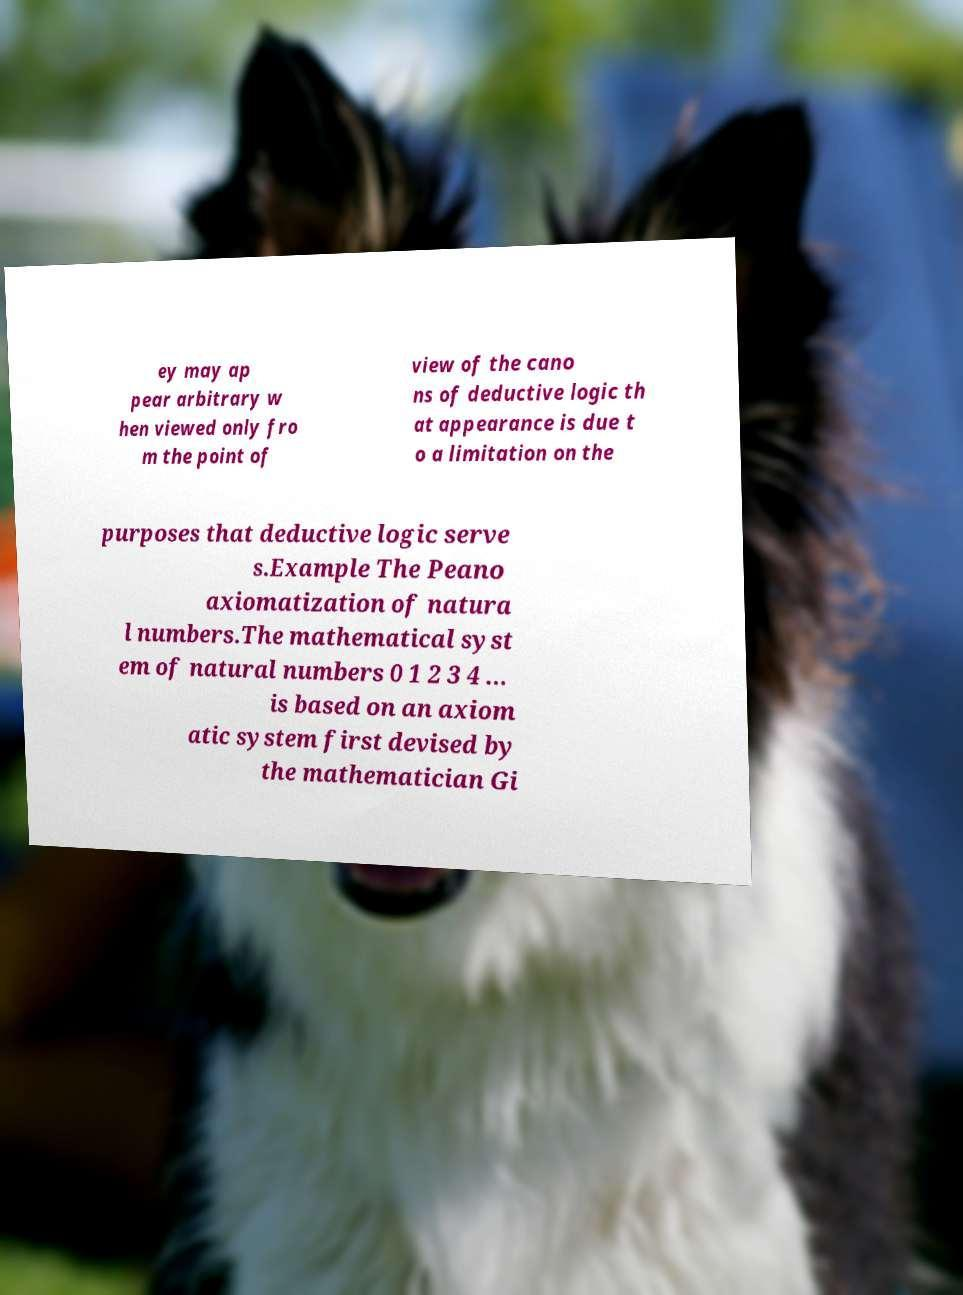Please read and relay the text visible in this image. What does it say? ey may ap pear arbitrary w hen viewed only fro m the point of view of the cano ns of deductive logic th at appearance is due t o a limitation on the purposes that deductive logic serve s.Example The Peano axiomatization of natura l numbers.The mathematical syst em of natural numbers 0 1 2 3 4 ... is based on an axiom atic system first devised by the mathematician Gi 